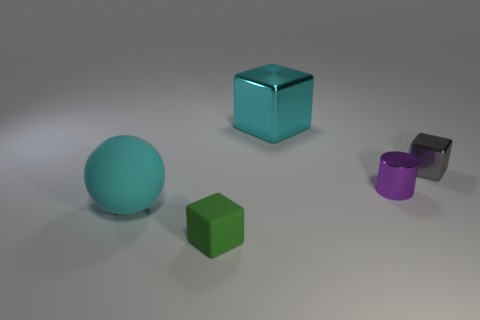Subtract all large blocks. How many blocks are left? 2 Add 4 big cyan metallic objects. How many objects exist? 9 Subtract all blue cubes. Subtract all red cylinders. How many cubes are left? 3 Subtract all cylinders. How many objects are left? 4 Add 1 purple matte objects. How many purple matte objects exist? 1 Subtract 0 green spheres. How many objects are left? 5 Subtract all purple metal things. Subtract all gray matte cylinders. How many objects are left? 4 Add 4 cubes. How many cubes are left? 7 